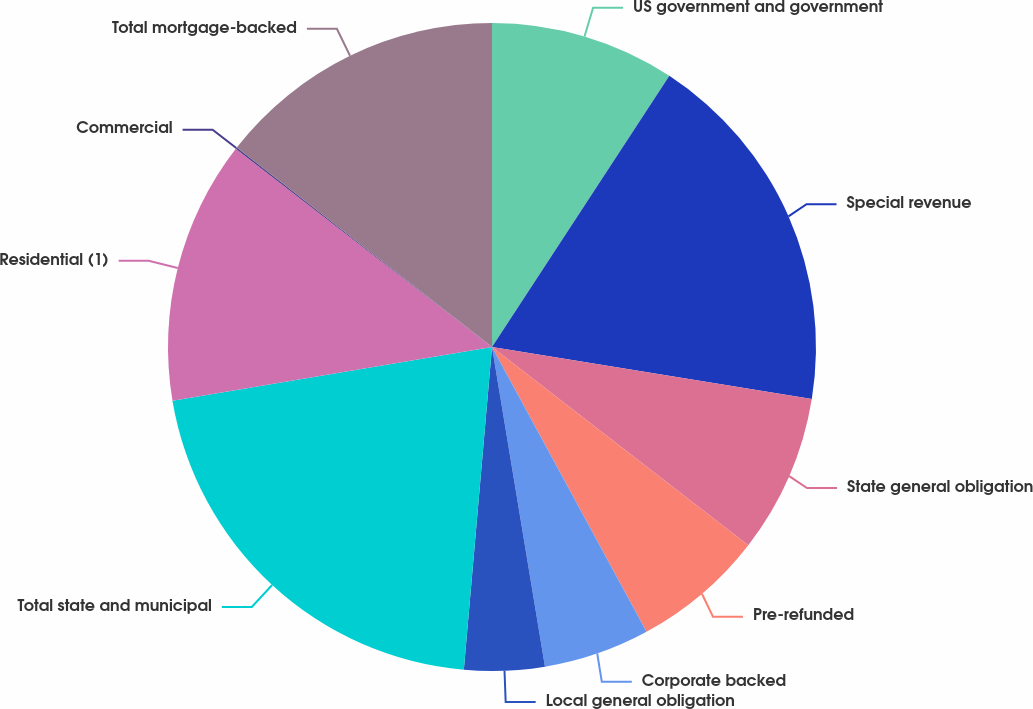Convert chart to OTSL. <chart><loc_0><loc_0><loc_500><loc_500><pie_chart><fcel>US government and government<fcel>Special revenue<fcel>State general obligation<fcel>Pre-refunded<fcel>Corporate backed<fcel>Local general obligation<fcel>Total state and municipal<fcel>Residential (1)<fcel>Commercial<fcel>Total mortgage-backed<nl><fcel>9.22%<fcel>18.35%<fcel>7.91%<fcel>6.61%<fcel>5.3%<fcel>4.0%<fcel>20.97%<fcel>13.13%<fcel>0.08%<fcel>14.44%<nl></chart> 